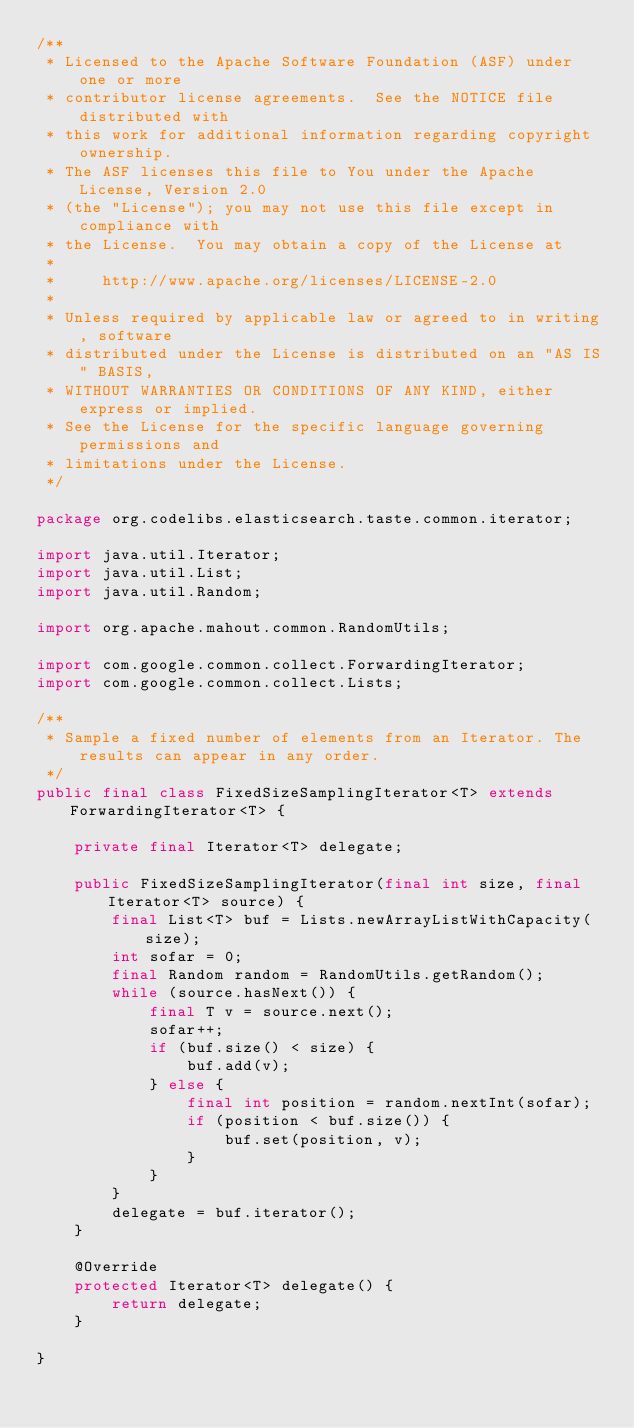<code> <loc_0><loc_0><loc_500><loc_500><_Java_>/**
 * Licensed to the Apache Software Foundation (ASF) under one or more
 * contributor license agreements.  See the NOTICE file distributed with
 * this work for additional information regarding copyright ownership.
 * The ASF licenses this file to You under the Apache License, Version 2.0
 * (the "License"); you may not use this file except in compliance with
 * the License.  You may obtain a copy of the License at
 *
 *     http://www.apache.org/licenses/LICENSE-2.0
 *
 * Unless required by applicable law or agreed to in writing, software
 * distributed under the License is distributed on an "AS IS" BASIS,
 * WITHOUT WARRANTIES OR CONDITIONS OF ANY KIND, either express or implied.
 * See the License for the specific language governing permissions and
 * limitations under the License.
 */

package org.codelibs.elasticsearch.taste.common.iterator;

import java.util.Iterator;
import java.util.List;
import java.util.Random;

import org.apache.mahout.common.RandomUtils;

import com.google.common.collect.ForwardingIterator;
import com.google.common.collect.Lists;

/**
 * Sample a fixed number of elements from an Iterator. The results can appear in any order.
 */
public final class FixedSizeSamplingIterator<T> extends ForwardingIterator<T> {

    private final Iterator<T> delegate;

    public FixedSizeSamplingIterator(final int size, final Iterator<T> source) {
        final List<T> buf = Lists.newArrayListWithCapacity(size);
        int sofar = 0;
        final Random random = RandomUtils.getRandom();
        while (source.hasNext()) {
            final T v = source.next();
            sofar++;
            if (buf.size() < size) {
                buf.add(v);
            } else {
                final int position = random.nextInt(sofar);
                if (position < buf.size()) {
                    buf.set(position, v);
                }
            }
        }
        delegate = buf.iterator();
    }

    @Override
    protected Iterator<T> delegate() {
        return delegate;
    }

}
</code> 